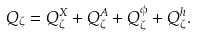Convert formula to latex. <formula><loc_0><loc_0><loc_500><loc_500>Q _ { \zeta } = Q _ { \zeta } ^ { X } + Q _ { \zeta } ^ { A } + Q _ { \zeta } ^ { \phi } + Q _ { \zeta } ^ { h } .</formula> 